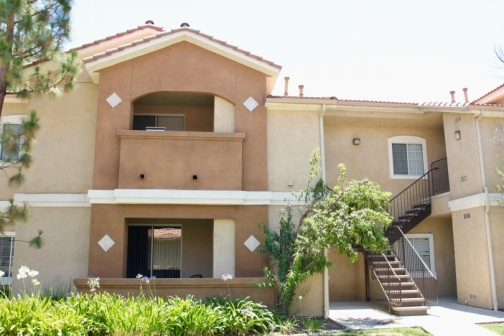Think about a movie scene that could take place here. Describe the setting and action. In a romantic drama, this apartment complex could be the setting for heartfelt reunions and emotional departures. The protagonist might rush up the stairs to the second-floor balcony, where they finally confess their love under the gentle afternoon sun. The well-kept garden would be the backdrop for quiet, intimate conversations, while the patio could be the site of neighborhood gatherings, filled with laughter and camaraderie. The quiet ambiance heightens the emotional depth of each scene, making it a memorable part of the film. 